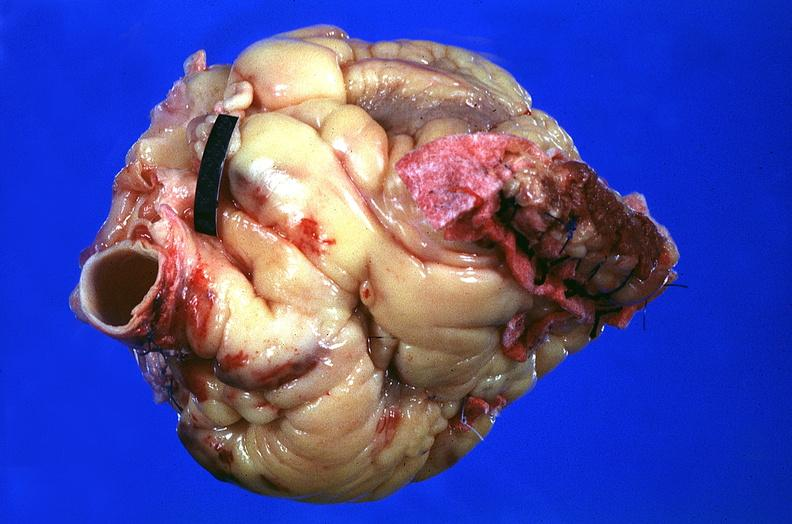s cardiovascular present?
Answer the question using a single word or phrase. Yes 